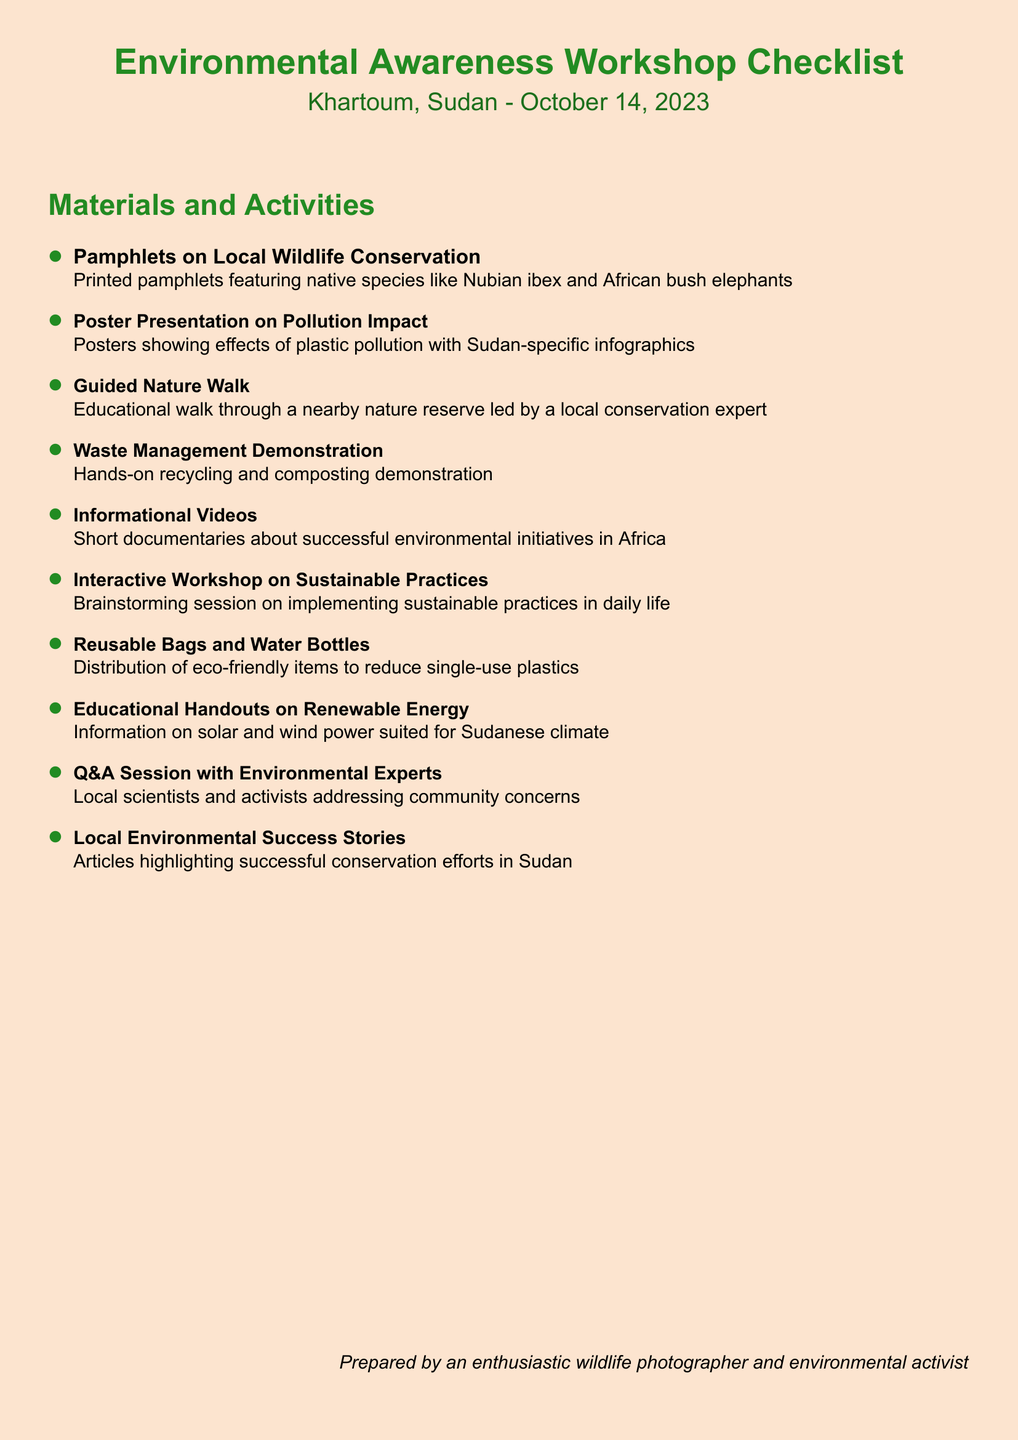What is the date of the workshop? The date of the workshop is specified in the document as October 14, 2023.
Answer: October 14, 2023 What type of wildlife is featured in the pamphlets? The pamphlets include information on native species, specifically mentioning the Nubian ibex and African bush elephants.
Answer: Nubian ibex and African bush elephants What activity involves a local conservation expert? The document describes a Guided Nature Walk that is led by a local conservation expert.
Answer: Guided Nature Walk How many materials are listed in the checklist? The checklist contains ten different materials and activities planned for the workshop.
Answer: 10 What is the purpose of the Reusable Bags and Water Bottles? The document states that these items are distributed to reduce single-use plastics, highlighting their environmental purpose.
Answer: To reduce single-use plastics What type of session allows community members to ask questions? The document mentions a Q&A Session where local scientists and activists can address community concerns.
Answer: Q&A Session Which sustainability topic will be discussed in the interactive workshop? The Interactive Workshop on Sustainable Practices focuses on brainstorming ways to implement sustainable practices in daily life.
Answer: Sustainable Practices What educational tool features infographics? The Poster Presentation on Pollution Impact includes Sudan-specific infographics related to the effects of plastic pollution.
Answer: Poster Presentation What is highlighted in the Local Environmental Success Stories? Articles within this section focus on showcasing successful conservation efforts that have taken place in Sudan.
Answer: Successful conservation efforts in Sudan 